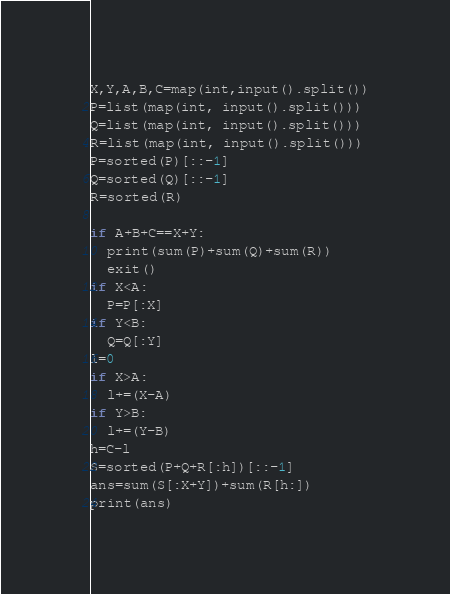Convert code to text. <code><loc_0><loc_0><loc_500><loc_500><_Python_>X,Y,A,B,C=map(int,input().split())
P=list(map(int, input().split()))
Q=list(map(int, input().split()))
R=list(map(int, input().split()))
P=sorted(P)[::-1]
Q=sorted(Q)[::-1]
R=sorted(R)

if A+B+C==X+Y:
  print(sum(P)+sum(Q)+sum(R))
  exit()
if X<A:
  P=P[:X]
if Y<B:
  Q=Q[:Y]
l=0
if X>A:
  l+=(X-A)
if Y>B:
  l+=(Y-B)
h=C-l
S=sorted(P+Q+R[:h])[::-1]
ans=sum(S[:X+Y])+sum(R[h:])
print(ans)</code> 